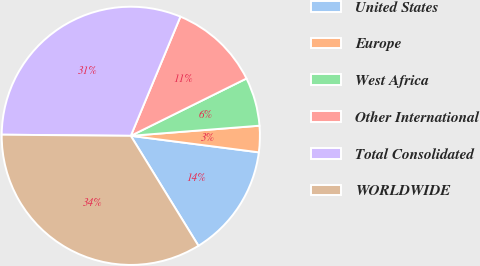Convert chart. <chart><loc_0><loc_0><loc_500><loc_500><pie_chart><fcel>United States<fcel>Europe<fcel>West Africa<fcel>Other International<fcel>Total Consolidated<fcel>WORLDWIDE<nl><fcel>14.18%<fcel>3.29%<fcel>6.07%<fcel>11.4%<fcel>31.14%<fcel>33.92%<nl></chart> 